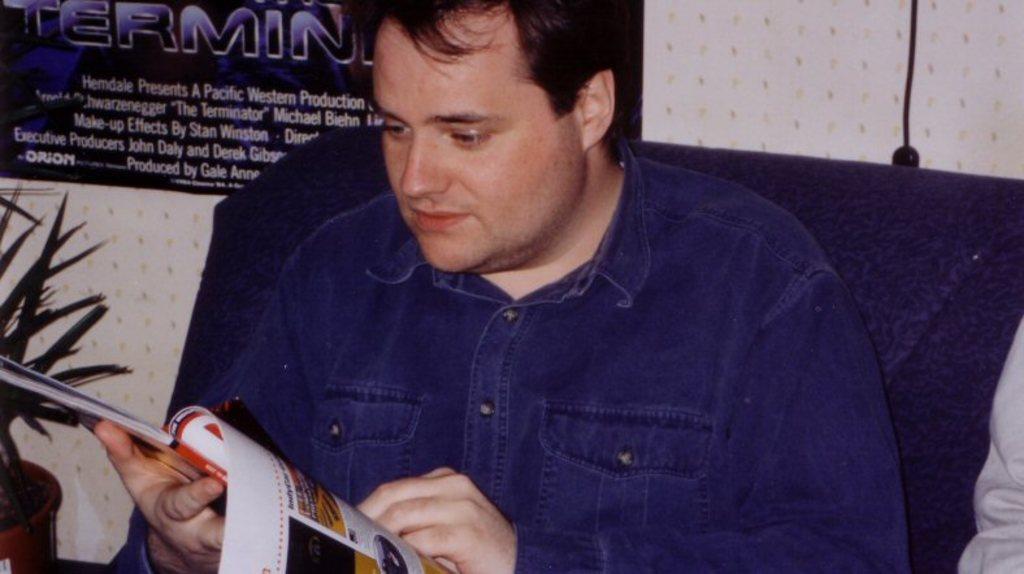How would you summarize this image in a sentence or two? In this image we can see a man holding the book and sitting. In the background we can see the poster with the text. We can also see the plant, wire, wall and also some person on the right. 